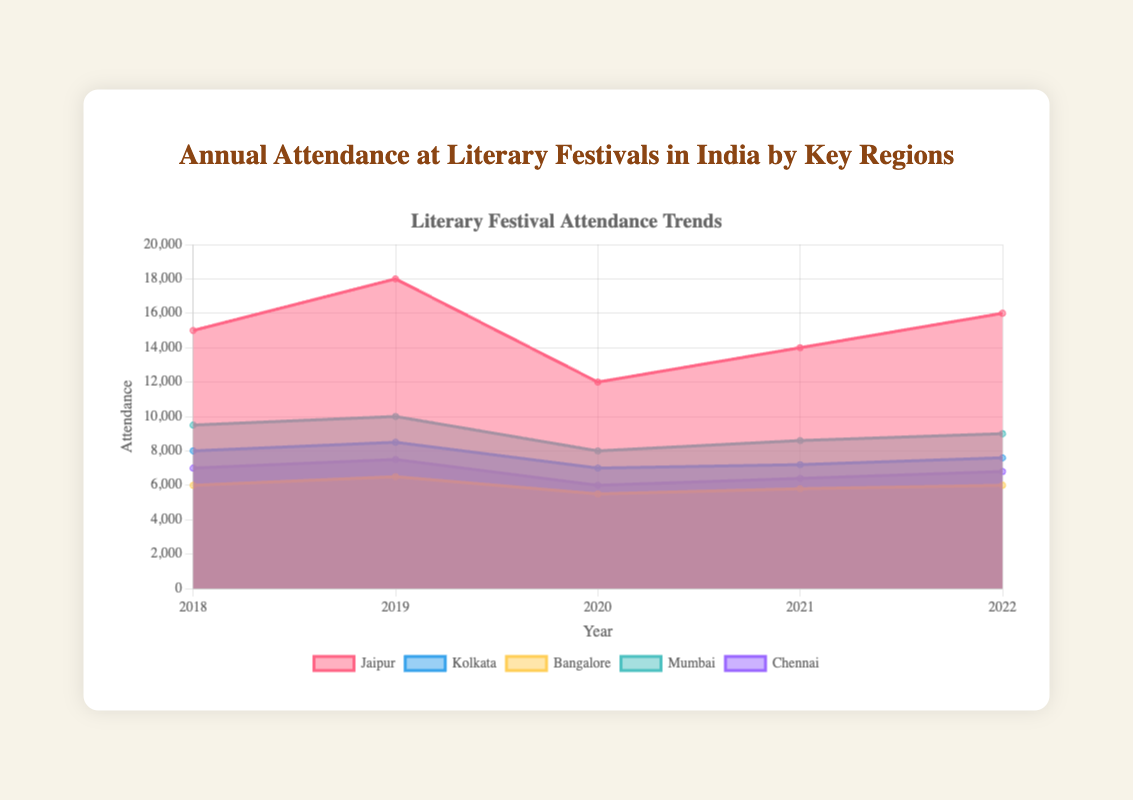What is the highest attendance recorded for Jaipur? The highest attendance for Jaipur can be found by inspecting the data points for Jaipur over the years. The highest value among these is 18000 in the year 2019.
Answer: 18000 Which year had the lowest attendance in Kolkata? By examining the trend for Kolkata across the years, the lowest attendance value is seen in 2020, which is 7000.
Answer: 2020 How does the attendance in Mumbai in 2022 compare to that in 2018? Attendance in Mumbai in 2022 is 9000, while in 2018 it was 9500. Therefore, the attendance decreased in 2022 compared to 2018.
Answer: Decreased What is the total attendance for Bangalore over all years? Summing the values for Bangalore from all the years: 6000 (2018) + 6500 (2019) + 5500 (2020) + 5800 (2021) + 6000 (2022) equals 29800.
Answer: 29800 Which city had the most consistent attendance numbers over the years? The consistency can be judged by looking at the least fluctuation in values. Bangalore shows the smallest range from 5500 to 6500, indicating it had the most consistent attendance.
Answer: Bangalore In 2020, which city had the second-lowest attendance? The attendance values for 2020 are 12000 (Jaipur), 7000 (Kolkata), 5500 (Bangalore), 8000 (Mumbai), 6000 (Chennai). The second-lowest attendance is for Chennai with 6000.
Answer: Chennai What is the average annual attendance for Chennai across the five years? Sum the attendance values for Chennai and divide by 5: (7000+7500+6000+6400+6800)/5 which equals 6740.
Answer: 6740 Compare the trends in the attendance of Jaipur and Mumbai. Jaipur shows a slightly fluctuating increase with a dip in 2020, while Mumbai displays a consistent rise and drop pattern. Overall, both have ups and downs but follow different patterns.
Answer: Different patterns How did the attendance in Kolkata change from 2021 to 2022? Attendance in Kolkata was 7200 in 2021 and increased to 7600 in 2022.
Answer: Increased Considering the attendance values for all cities in 2019, which city had the highest number? By comparing the 2019 attendance values: Jaipur (18000), Kolkata (8500), Bangalore (6500), Mumbai (10000), Chennai (7500). Jaipur had the highest attendance with 18000.
Answer: Jaipur 